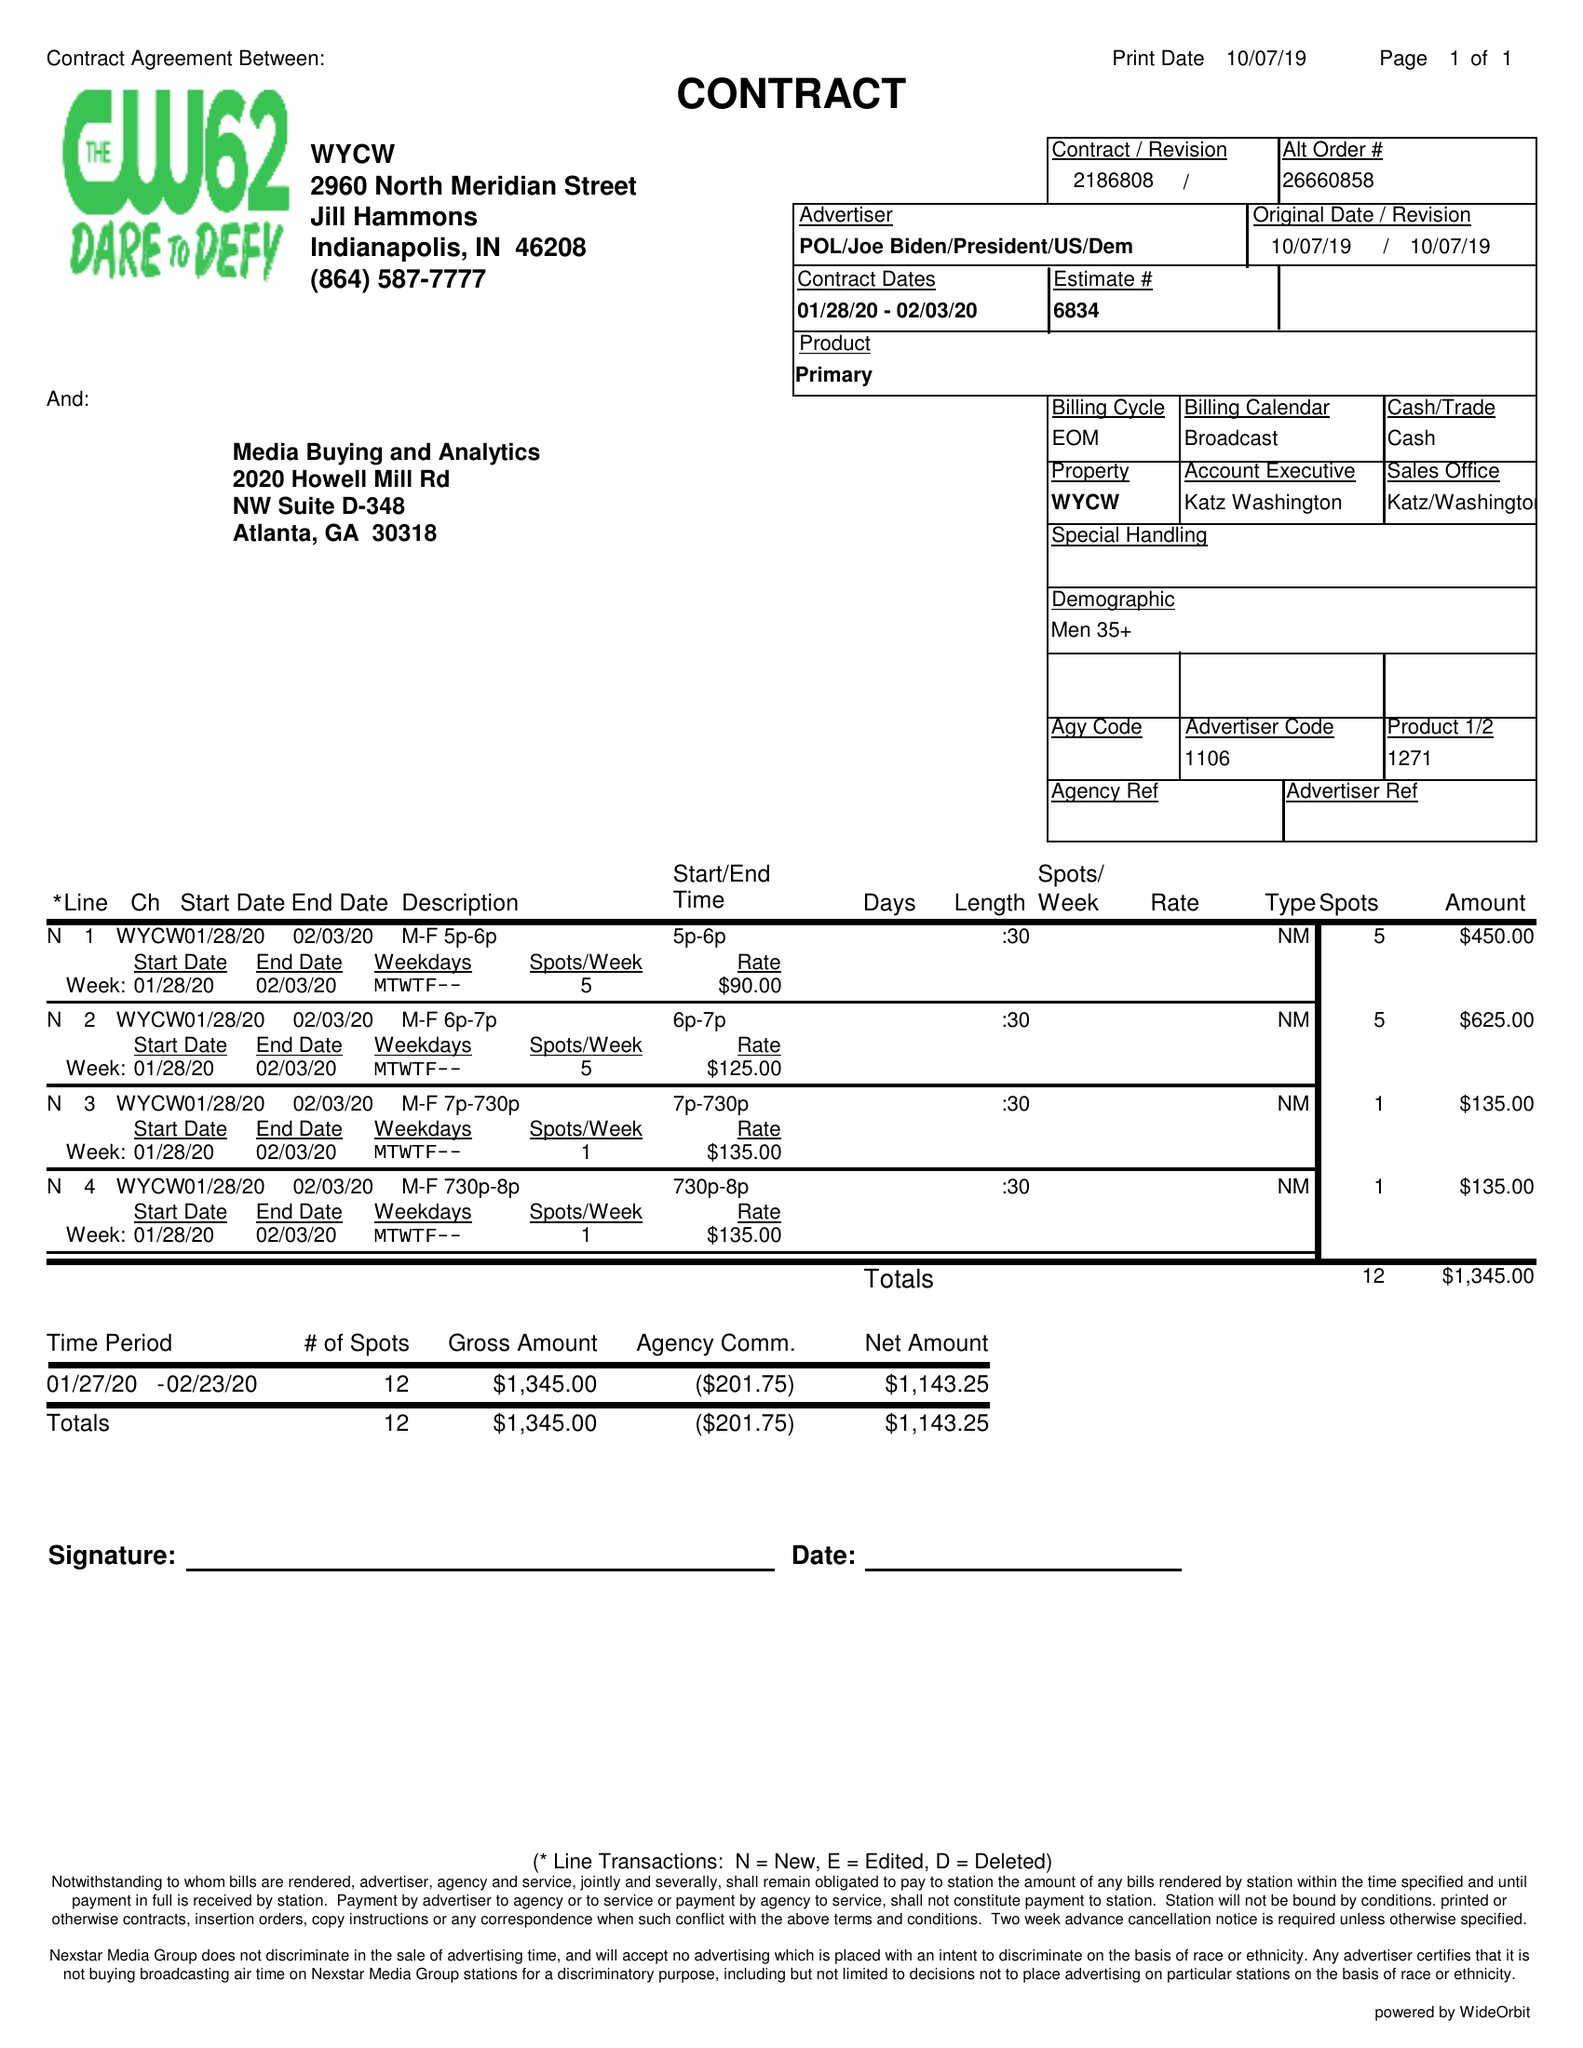What is the value for the gross_amount?
Answer the question using a single word or phrase. 1345.00 